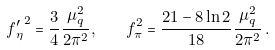<formula> <loc_0><loc_0><loc_500><loc_500>f { _ { \eta } ^ { \prime } } ^ { 2 } = \frac { 3 } { 4 } \frac { \mu _ { q } ^ { 2 } } { 2 \pi ^ { 2 } } , \quad f _ { \pi } ^ { 2 } = \frac { 2 1 - 8 \ln 2 } { 1 8 } \frac { \mu _ { q } ^ { 2 } } { 2 \pi ^ { 2 } } \, .</formula> 